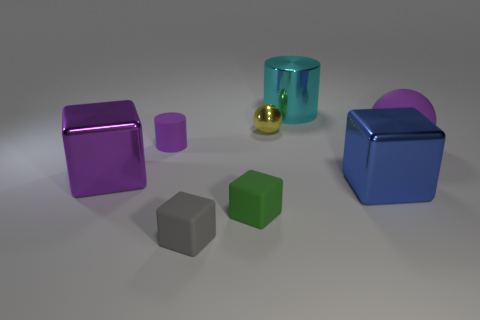Does the yellow shiny object have the same shape as the tiny gray thing?
Keep it short and to the point. No. What number of other objects are there of the same shape as the big cyan thing?
Give a very brief answer. 1. There is a cylinder that is the same size as the rubber ball; what color is it?
Provide a succinct answer. Cyan. Are there the same number of big metal cylinders on the left side of the small green matte block and tiny purple rubber balls?
Your answer should be compact. Yes. The purple object that is in front of the small purple matte cylinder and left of the blue shiny block has what shape?
Give a very brief answer. Cube. Do the gray block and the cyan metallic cylinder have the same size?
Your answer should be compact. No. Is there a yellow object that has the same material as the purple cylinder?
Keep it short and to the point. No. There is a metal cube that is the same color as the small rubber cylinder; what size is it?
Offer a very short reply. Large. How many metal objects are both in front of the tiny cylinder and on the right side of the small purple rubber cylinder?
Keep it short and to the point. 1. There is a cylinder to the left of the yellow thing; what material is it?
Offer a very short reply. Rubber. 